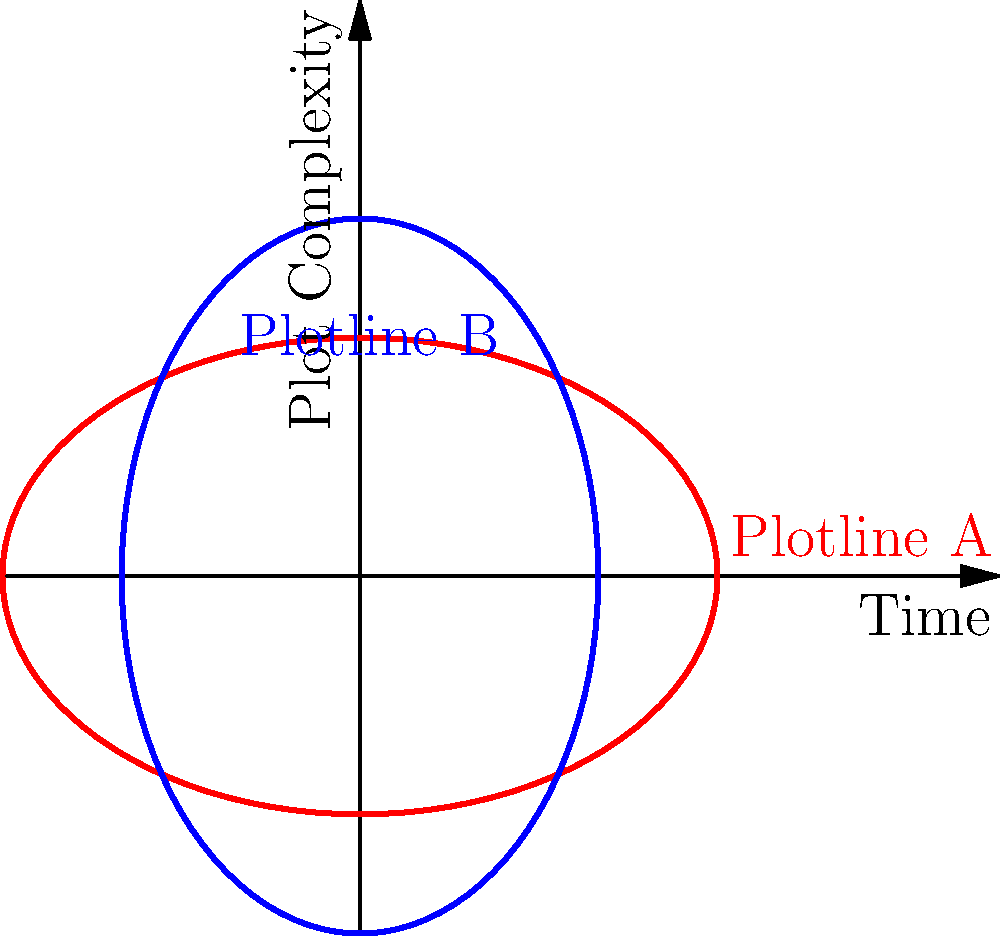In Christopher Nolan's "Inception," two intertwining plotlines can be represented by parametric equations. Plotline A is given by $x = 3\cos(t)$, $y = 2\sin(t)$, and Plotline B by $x = 2\cos(t+\frac{\pi}{4})$, $y = 3\sin(t+\frac{\pi}{4})$. At what value of $t$ do these plotlines intersect, symbolizing a crucial moment where the dream layers converge? To find the intersection point, we need to solve the system of equations:

1) $3\cos(t) = 2\cos(t+\frac{\pi}{4})$
2) $2\sin(t) = 3\sin(t+\frac{\pi}{4})$

Let's approach this step-by-step:

1) Square both sides of each equation:
   $9\cos^2(t) = 4\cos^2(t+\frac{\pi}{4})$
   $4\sin^2(t) = 9\sin^2(t+\frac{\pi}{4})$

2) Add these equations:
   $9\cos^2(t) + 4\sin^2(t) = 4\cos^2(t+\frac{\pi}{4}) + 9\sin^2(t+\frac{\pi}{4})$

3) Use the identity $\cos^2(\theta) + \sin^2(\theta) = 1$:
   $9\cos^2(t) + 4\sin^2(t) = 4(1-\sin^2(t+\frac{\pi}{4})) + 9\sin^2(t+\frac{\pi}{4})$
   $9\cos^2(t) + 4\sin^2(t) = 4 + 5\sin^2(t+\frac{\pi}{4})$

4) Substitute $\cos^2(t) = 1 - \sin^2(t)$:
   $9(1-\sin^2(t)) + 4\sin^2(t) = 4 + 5\sin^2(t+\frac{\pi}{4})$
   $9 - 9\sin^2(t) + 4\sin^2(t) = 4 + 5\sin^2(t+\frac{\pi}{4})$
   $9 - 5\sin^2(t) = 4 + 5\sin^2(t+\frac{\pi}{4})$
   $5 = 5\sin^2(t) + 5\sin^2(t+\frac{\pi}{4})$

5) Use the identity $\sin^2(A) + \sin^2(A+\frac{\pi}{4}) = 1$:
   $5 = 5(1) = 5$

This is always true, meaning the curves intersect at infinitely many points. The first intersection occurs at $t = \frac{\pi}{8}$, which can be verified by substituting back into the original equations.
Answer: $t = \frac{\pi}{8}$ 